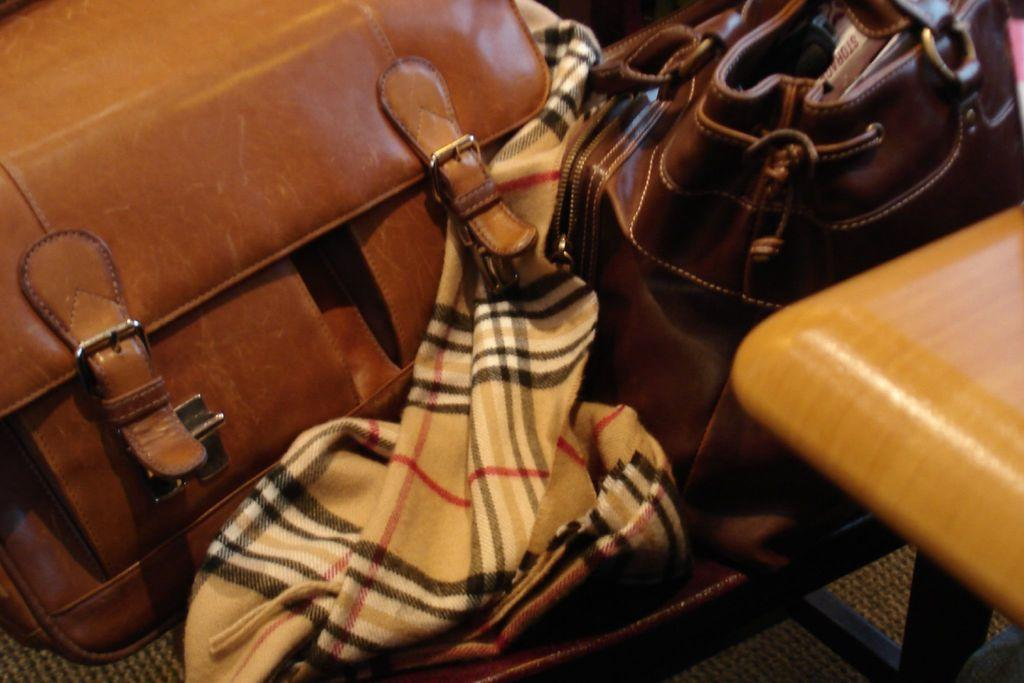What type of objects can be seen in the image? There are bags in the image. What material is present in the image? There is cloth in the image. What type of structure is being discussed in the image? There is no discussion or structure present in the image; it only features bags and cloth. 